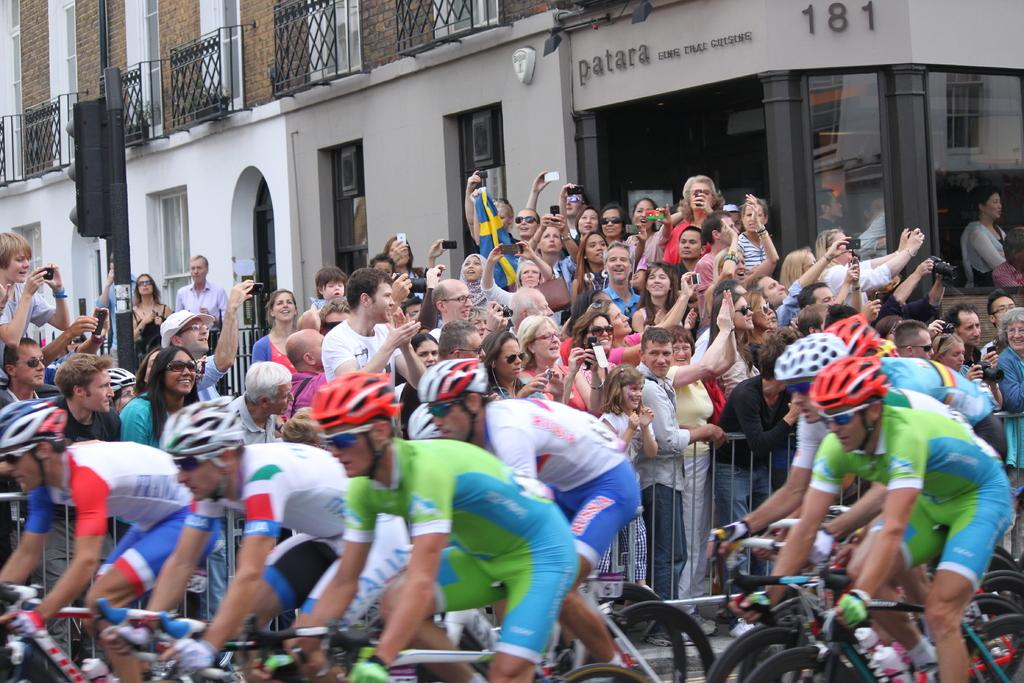What is the main subject of the image? The main subject of the image is a crowd. What are some people in the crowd doing? Some people in the crowd are sitting on bicycles. What can be seen in the background of the image? There is a building in the background of the image. What are some people in the crowd holding? Some people in the crowd are holding mobiles and cameras. What is the title of the painting in the image? There is no painting or title present in the image; it features a crowd of people. What type of canvas is visible in the image? There is no canvas present in the image. 